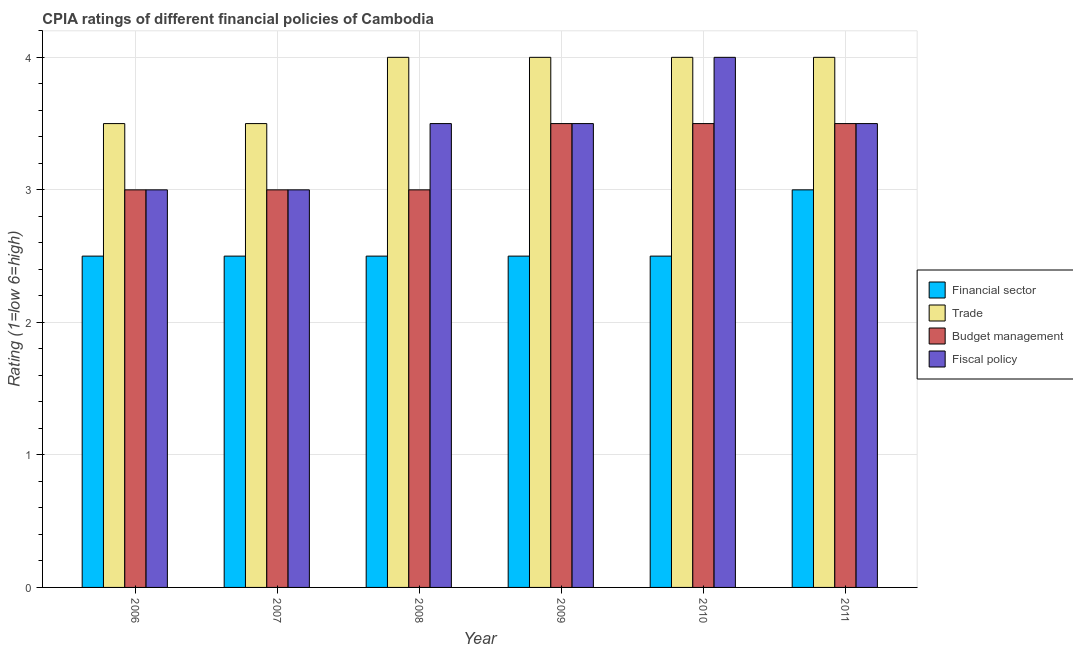How many different coloured bars are there?
Your answer should be compact. 4. Are the number of bars per tick equal to the number of legend labels?
Offer a terse response. Yes. Are the number of bars on each tick of the X-axis equal?
Offer a very short reply. Yes. How many bars are there on the 2nd tick from the right?
Make the answer very short. 4. In how many cases, is the number of bars for a given year not equal to the number of legend labels?
Provide a succinct answer. 0. Across all years, what is the maximum cpia rating of financial sector?
Give a very brief answer. 3. In which year was the cpia rating of fiscal policy maximum?
Your answer should be compact. 2010. In which year was the cpia rating of budget management minimum?
Your answer should be very brief. 2006. What is the difference between the cpia rating of fiscal policy in 2010 and the cpia rating of trade in 2006?
Your answer should be compact. 1. What is the average cpia rating of fiscal policy per year?
Ensure brevity in your answer.  3.42. In the year 2006, what is the difference between the cpia rating of budget management and cpia rating of fiscal policy?
Keep it short and to the point. 0. In how many years, is the cpia rating of financial sector greater than 1.6?
Your answer should be very brief. 6. What is the ratio of the cpia rating of financial sector in 2006 to that in 2009?
Your answer should be very brief. 1. Is the cpia rating of fiscal policy in 2010 less than that in 2011?
Offer a very short reply. No. What is the difference between the highest and the second highest cpia rating of fiscal policy?
Provide a short and direct response. 0.5. What is the difference between the highest and the lowest cpia rating of financial sector?
Offer a terse response. 0.5. Is it the case that in every year, the sum of the cpia rating of trade and cpia rating of budget management is greater than the sum of cpia rating of financial sector and cpia rating of fiscal policy?
Your answer should be very brief. No. What does the 3rd bar from the left in 2010 represents?
Ensure brevity in your answer.  Budget management. What does the 3rd bar from the right in 2008 represents?
Ensure brevity in your answer.  Trade. Is it the case that in every year, the sum of the cpia rating of financial sector and cpia rating of trade is greater than the cpia rating of budget management?
Offer a terse response. Yes. How many years are there in the graph?
Your answer should be very brief. 6. Does the graph contain grids?
Offer a very short reply. Yes. How many legend labels are there?
Ensure brevity in your answer.  4. How are the legend labels stacked?
Make the answer very short. Vertical. What is the title of the graph?
Provide a succinct answer. CPIA ratings of different financial policies of Cambodia. What is the Rating (1=low 6=high) in Financial sector in 2006?
Make the answer very short. 2.5. What is the Rating (1=low 6=high) of Fiscal policy in 2006?
Provide a succinct answer. 3. What is the Rating (1=low 6=high) in Financial sector in 2007?
Offer a very short reply. 2.5. What is the Rating (1=low 6=high) of Trade in 2007?
Your response must be concise. 3.5. What is the Rating (1=low 6=high) of Fiscal policy in 2007?
Your answer should be very brief. 3. What is the Rating (1=low 6=high) in Trade in 2008?
Offer a terse response. 4. What is the Rating (1=low 6=high) of Budget management in 2008?
Offer a terse response. 3. What is the Rating (1=low 6=high) of Fiscal policy in 2008?
Ensure brevity in your answer.  3.5. What is the Rating (1=low 6=high) in Trade in 2009?
Provide a succinct answer. 4. What is the Rating (1=low 6=high) in Budget management in 2009?
Give a very brief answer. 3.5. What is the Rating (1=low 6=high) in Fiscal policy in 2009?
Ensure brevity in your answer.  3.5. What is the Rating (1=low 6=high) in Financial sector in 2010?
Offer a very short reply. 2.5. What is the Rating (1=low 6=high) in Trade in 2010?
Your answer should be compact. 4. What is the Rating (1=low 6=high) in Financial sector in 2011?
Ensure brevity in your answer.  3. Across all years, what is the maximum Rating (1=low 6=high) in Financial sector?
Your answer should be compact. 3. Across all years, what is the maximum Rating (1=low 6=high) in Trade?
Make the answer very short. 4. Across all years, what is the maximum Rating (1=low 6=high) of Fiscal policy?
Offer a terse response. 4. Across all years, what is the minimum Rating (1=low 6=high) in Budget management?
Give a very brief answer. 3. Across all years, what is the minimum Rating (1=low 6=high) in Fiscal policy?
Give a very brief answer. 3. What is the total Rating (1=low 6=high) of Financial sector in the graph?
Your answer should be compact. 15.5. What is the total Rating (1=low 6=high) in Trade in the graph?
Offer a terse response. 23. What is the total Rating (1=low 6=high) in Fiscal policy in the graph?
Your response must be concise. 20.5. What is the difference between the Rating (1=low 6=high) in Financial sector in 2006 and that in 2007?
Keep it short and to the point. 0. What is the difference between the Rating (1=low 6=high) in Fiscal policy in 2006 and that in 2007?
Ensure brevity in your answer.  0. What is the difference between the Rating (1=low 6=high) of Trade in 2006 and that in 2008?
Your answer should be very brief. -0.5. What is the difference between the Rating (1=low 6=high) of Budget management in 2006 and that in 2008?
Your answer should be very brief. 0. What is the difference between the Rating (1=low 6=high) of Fiscal policy in 2006 and that in 2008?
Ensure brevity in your answer.  -0.5. What is the difference between the Rating (1=low 6=high) of Financial sector in 2006 and that in 2009?
Make the answer very short. 0. What is the difference between the Rating (1=low 6=high) of Budget management in 2006 and that in 2009?
Ensure brevity in your answer.  -0.5. What is the difference between the Rating (1=low 6=high) in Fiscal policy in 2006 and that in 2009?
Your answer should be very brief. -0.5. What is the difference between the Rating (1=low 6=high) in Financial sector in 2006 and that in 2010?
Your answer should be compact. 0. What is the difference between the Rating (1=low 6=high) in Fiscal policy in 2006 and that in 2010?
Your answer should be compact. -1. What is the difference between the Rating (1=low 6=high) in Financial sector in 2006 and that in 2011?
Provide a succinct answer. -0.5. What is the difference between the Rating (1=low 6=high) in Trade in 2006 and that in 2011?
Your answer should be very brief. -0.5. What is the difference between the Rating (1=low 6=high) of Budget management in 2006 and that in 2011?
Ensure brevity in your answer.  -0.5. What is the difference between the Rating (1=low 6=high) in Fiscal policy in 2006 and that in 2011?
Offer a very short reply. -0.5. What is the difference between the Rating (1=low 6=high) of Financial sector in 2007 and that in 2008?
Keep it short and to the point. 0. What is the difference between the Rating (1=low 6=high) in Trade in 2007 and that in 2008?
Offer a terse response. -0.5. What is the difference between the Rating (1=low 6=high) in Budget management in 2007 and that in 2008?
Offer a terse response. 0. What is the difference between the Rating (1=low 6=high) of Fiscal policy in 2007 and that in 2008?
Your response must be concise. -0.5. What is the difference between the Rating (1=low 6=high) in Trade in 2007 and that in 2009?
Make the answer very short. -0.5. What is the difference between the Rating (1=low 6=high) in Fiscal policy in 2007 and that in 2010?
Your answer should be very brief. -1. What is the difference between the Rating (1=low 6=high) of Trade in 2007 and that in 2011?
Provide a short and direct response. -0.5. What is the difference between the Rating (1=low 6=high) of Budget management in 2007 and that in 2011?
Keep it short and to the point. -0.5. What is the difference between the Rating (1=low 6=high) in Financial sector in 2008 and that in 2010?
Your answer should be very brief. 0. What is the difference between the Rating (1=low 6=high) in Trade in 2008 and that in 2010?
Your response must be concise. 0. What is the difference between the Rating (1=low 6=high) of Budget management in 2008 and that in 2010?
Your answer should be very brief. -0.5. What is the difference between the Rating (1=low 6=high) in Budget management in 2008 and that in 2011?
Ensure brevity in your answer.  -0.5. What is the difference between the Rating (1=low 6=high) in Budget management in 2009 and that in 2010?
Give a very brief answer. 0. What is the difference between the Rating (1=low 6=high) of Fiscal policy in 2009 and that in 2010?
Your answer should be compact. -0.5. What is the difference between the Rating (1=low 6=high) in Trade in 2009 and that in 2011?
Your response must be concise. 0. What is the difference between the Rating (1=low 6=high) in Financial sector in 2010 and that in 2011?
Make the answer very short. -0.5. What is the difference between the Rating (1=low 6=high) of Financial sector in 2006 and the Rating (1=low 6=high) of Fiscal policy in 2008?
Ensure brevity in your answer.  -1. What is the difference between the Rating (1=low 6=high) of Trade in 2006 and the Rating (1=low 6=high) of Fiscal policy in 2008?
Keep it short and to the point. 0. What is the difference between the Rating (1=low 6=high) of Budget management in 2006 and the Rating (1=low 6=high) of Fiscal policy in 2008?
Provide a succinct answer. -0.5. What is the difference between the Rating (1=low 6=high) of Financial sector in 2006 and the Rating (1=low 6=high) of Trade in 2009?
Keep it short and to the point. -1.5. What is the difference between the Rating (1=low 6=high) of Financial sector in 2006 and the Rating (1=low 6=high) of Fiscal policy in 2009?
Ensure brevity in your answer.  -1. What is the difference between the Rating (1=low 6=high) in Trade in 2006 and the Rating (1=low 6=high) in Fiscal policy in 2009?
Offer a terse response. 0. What is the difference between the Rating (1=low 6=high) in Financial sector in 2006 and the Rating (1=low 6=high) in Fiscal policy in 2010?
Give a very brief answer. -1.5. What is the difference between the Rating (1=low 6=high) of Trade in 2006 and the Rating (1=low 6=high) of Fiscal policy in 2010?
Offer a very short reply. -0.5. What is the difference between the Rating (1=low 6=high) of Financial sector in 2006 and the Rating (1=low 6=high) of Trade in 2011?
Your answer should be very brief. -1.5. What is the difference between the Rating (1=low 6=high) of Financial sector in 2006 and the Rating (1=low 6=high) of Budget management in 2011?
Ensure brevity in your answer.  -1. What is the difference between the Rating (1=low 6=high) in Financial sector in 2006 and the Rating (1=low 6=high) in Fiscal policy in 2011?
Ensure brevity in your answer.  -1. What is the difference between the Rating (1=low 6=high) of Trade in 2006 and the Rating (1=low 6=high) of Budget management in 2011?
Ensure brevity in your answer.  0. What is the difference between the Rating (1=low 6=high) in Trade in 2006 and the Rating (1=low 6=high) in Fiscal policy in 2011?
Offer a terse response. 0. What is the difference between the Rating (1=low 6=high) of Financial sector in 2007 and the Rating (1=low 6=high) of Trade in 2008?
Make the answer very short. -1.5. What is the difference between the Rating (1=low 6=high) in Trade in 2007 and the Rating (1=low 6=high) in Budget management in 2008?
Your answer should be compact. 0.5. What is the difference between the Rating (1=low 6=high) of Trade in 2007 and the Rating (1=low 6=high) of Fiscal policy in 2008?
Offer a terse response. 0. What is the difference between the Rating (1=low 6=high) of Budget management in 2007 and the Rating (1=low 6=high) of Fiscal policy in 2008?
Your answer should be compact. -0.5. What is the difference between the Rating (1=low 6=high) in Financial sector in 2007 and the Rating (1=low 6=high) in Trade in 2009?
Keep it short and to the point. -1.5. What is the difference between the Rating (1=low 6=high) of Financial sector in 2007 and the Rating (1=low 6=high) of Fiscal policy in 2009?
Offer a very short reply. -1. What is the difference between the Rating (1=low 6=high) of Financial sector in 2007 and the Rating (1=low 6=high) of Budget management in 2010?
Offer a terse response. -1. What is the difference between the Rating (1=low 6=high) of Financial sector in 2007 and the Rating (1=low 6=high) of Fiscal policy in 2010?
Provide a succinct answer. -1.5. What is the difference between the Rating (1=low 6=high) of Trade in 2007 and the Rating (1=low 6=high) of Budget management in 2010?
Give a very brief answer. 0. What is the difference between the Rating (1=low 6=high) of Trade in 2007 and the Rating (1=low 6=high) of Fiscal policy in 2010?
Provide a short and direct response. -0.5. What is the difference between the Rating (1=low 6=high) in Financial sector in 2007 and the Rating (1=low 6=high) in Budget management in 2011?
Your response must be concise. -1. What is the difference between the Rating (1=low 6=high) of Financial sector in 2007 and the Rating (1=low 6=high) of Fiscal policy in 2011?
Your response must be concise. -1. What is the difference between the Rating (1=low 6=high) of Trade in 2007 and the Rating (1=low 6=high) of Budget management in 2011?
Your answer should be compact. 0. What is the difference between the Rating (1=low 6=high) of Budget management in 2007 and the Rating (1=low 6=high) of Fiscal policy in 2011?
Give a very brief answer. -0.5. What is the difference between the Rating (1=low 6=high) of Financial sector in 2008 and the Rating (1=low 6=high) of Budget management in 2009?
Your answer should be very brief. -1. What is the difference between the Rating (1=low 6=high) of Financial sector in 2008 and the Rating (1=low 6=high) of Budget management in 2010?
Offer a terse response. -1. What is the difference between the Rating (1=low 6=high) in Financial sector in 2008 and the Rating (1=low 6=high) in Fiscal policy in 2010?
Ensure brevity in your answer.  -1.5. What is the difference between the Rating (1=low 6=high) in Budget management in 2008 and the Rating (1=low 6=high) in Fiscal policy in 2010?
Provide a short and direct response. -1. What is the difference between the Rating (1=low 6=high) of Financial sector in 2008 and the Rating (1=low 6=high) of Trade in 2011?
Make the answer very short. -1.5. What is the difference between the Rating (1=low 6=high) of Financial sector in 2008 and the Rating (1=low 6=high) of Budget management in 2011?
Ensure brevity in your answer.  -1. What is the difference between the Rating (1=low 6=high) in Trade in 2008 and the Rating (1=low 6=high) in Budget management in 2011?
Your answer should be very brief. 0.5. What is the difference between the Rating (1=low 6=high) in Trade in 2008 and the Rating (1=low 6=high) in Fiscal policy in 2011?
Your answer should be very brief. 0.5. What is the difference between the Rating (1=low 6=high) in Financial sector in 2009 and the Rating (1=low 6=high) in Trade in 2010?
Your response must be concise. -1.5. What is the difference between the Rating (1=low 6=high) in Financial sector in 2009 and the Rating (1=low 6=high) in Budget management in 2010?
Offer a very short reply. -1. What is the difference between the Rating (1=low 6=high) in Budget management in 2009 and the Rating (1=low 6=high) in Fiscal policy in 2010?
Keep it short and to the point. -0.5. What is the difference between the Rating (1=low 6=high) in Financial sector in 2009 and the Rating (1=low 6=high) in Trade in 2011?
Provide a succinct answer. -1.5. What is the difference between the Rating (1=low 6=high) in Trade in 2009 and the Rating (1=low 6=high) in Fiscal policy in 2011?
Keep it short and to the point. 0.5. What is the difference between the Rating (1=low 6=high) of Budget management in 2009 and the Rating (1=low 6=high) of Fiscal policy in 2011?
Keep it short and to the point. 0. What is the difference between the Rating (1=low 6=high) in Financial sector in 2010 and the Rating (1=low 6=high) in Trade in 2011?
Provide a short and direct response. -1.5. What is the difference between the Rating (1=low 6=high) of Financial sector in 2010 and the Rating (1=low 6=high) of Budget management in 2011?
Your response must be concise. -1. What is the difference between the Rating (1=low 6=high) of Trade in 2010 and the Rating (1=low 6=high) of Budget management in 2011?
Offer a very short reply. 0.5. What is the difference between the Rating (1=low 6=high) in Trade in 2010 and the Rating (1=low 6=high) in Fiscal policy in 2011?
Make the answer very short. 0.5. What is the difference between the Rating (1=low 6=high) of Budget management in 2010 and the Rating (1=low 6=high) of Fiscal policy in 2011?
Make the answer very short. 0. What is the average Rating (1=low 6=high) in Financial sector per year?
Make the answer very short. 2.58. What is the average Rating (1=low 6=high) in Trade per year?
Provide a succinct answer. 3.83. What is the average Rating (1=low 6=high) of Budget management per year?
Provide a short and direct response. 3.25. What is the average Rating (1=low 6=high) of Fiscal policy per year?
Your response must be concise. 3.42. In the year 2006, what is the difference between the Rating (1=low 6=high) in Financial sector and Rating (1=low 6=high) in Fiscal policy?
Offer a terse response. -0.5. In the year 2006, what is the difference between the Rating (1=low 6=high) of Trade and Rating (1=low 6=high) of Budget management?
Provide a succinct answer. 0.5. In the year 2007, what is the difference between the Rating (1=low 6=high) of Financial sector and Rating (1=low 6=high) of Budget management?
Provide a short and direct response. -0.5. In the year 2007, what is the difference between the Rating (1=low 6=high) of Trade and Rating (1=low 6=high) of Budget management?
Provide a succinct answer. 0.5. In the year 2008, what is the difference between the Rating (1=low 6=high) in Financial sector and Rating (1=low 6=high) in Fiscal policy?
Give a very brief answer. -1. In the year 2008, what is the difference between the Rating (1=low 6=high) of Trade and Rating (1=low 6=high) of Budget management?
Your answer should be very brief. 1. In the year 2009, what is the difference between the Rating (1=low 6=high) in Financial sector and Rating (1=low 6=high) in Trade?
Ensure brevity in your answer.  -1.5. In the year 2009, what is the difference between the Rating (1=low 6=high) in Financial sector and Rating (1=low 6=high) in Budget management?
Your answer should be very brief. -1. In the year 2009, what is the difference between the Rating (1=low 6=high) of Trade and Rating (1=low 6=high) of Budget management?
Provide a short and direct response. 0.5. In the year 2009, what is the difference between the Rating (1=low 6=high) of Trade and Rating (1=low 6=high) of Fiscal policy?
Provide a succinct answer. 0.5. In the year 2009, what is the difference between the Rating (1=low 6=high) of Budget management and Rating (1=low 6=high) of Fiscal policy?
Offer a very short reply. 0. In the year 2010, what is the difference between the Rating (1=low 6=high) in Financial sector and Rating (1=low 6=high) in Trade?
Keep it short and to the point. -1.5. In the year 2010, what is the difference between the Rating (1=low 6=high) of Financial sector and Rating (1=low 6=high) of Budget management?
Make the answer very short. -1. In the year 2010, what is the difference between the Rating (1=low 6=high) of Financial sector and Rating (1=low 6=high) of Fiscal policy?
Your response must be concise. -1.5. In the year 2010, what is the difference between the Rating (1=low 6=high) in Trade and Rating (1=low 6=high) in Budget management?
Make the answer very short. 0.5. In the year 2011, what is the difference between the Rating (1=low 6=high) of Trade and Rating (1=low 6=high) of Budget management?
Make the answer very short. 0.5. What is the ratio of the Rating (1=low 6=high) in Budget management in 2006 to that in 2007?
Provide a short and direct response. 1. What is the ratio of the Rating (1=low 6=high) in Trade in 2006 to that in 2008?
Make the answer very short. 0.88. What is the ratio of the Rating (1=low 6=high) of Budget management in 2006 to that in 2008?
Ensure brevity in your answer.  1. What is the ratio of the Rating (1=low 6=high) in Fiscal policy in 2006 to that in 2008?
Ensure brevity in your answer.  0.86. What is the ratio of the Rating (1=low 6=high) in Financial sector in 2006 to that in 2009?
Your answer should be compact. 1. What is the ratio of the Rating (1=low 6=high) of Trade in 2006 to that in 2009?
Your answer should be compact. 0.88. What is the ratio of the Rating (1=low 6=high) of Fiscal policy in 2006 to that in 2010?
Your answer should be very brief. 0.75. What is the ratio of the Rating (1=low 6=high) in Financial sector in 2006 to that in 2011?
Offer a very short reply. 0.83. What is the ratio of the Rating (1=low 6=high) of Trade in 2006 to that in 2011?
Make the answer very short. 0.88. What is the ratio of the Rating (1=low 6=high) of Budget management in 2006 to that in 2011?
Give a very brief answer. 0.86. What is the ratio of the Rating (1=low 6=high) of Fiscal policy in 2006 to that in 2011?
Offer a very short reply. 0.86. What is the ratio of the Rating (1=low 6=high) of Trade in 2007 to that in 2008?
Keep it short and to the point. 0.88. What is the ratio of the Rating (1=low 6=high) in Budget management in 2007 to that in 2008?
Give a very brief answer. 1. What is the ratio of the Rating (1=low 6=high) of Financial sector in 2007 to that in 2009?
Your answer should be very brief. 1. What is the ratio of the Rating (1=low 6=high) of Fiscal policy in 2007 to that in 2009?
Give a very brief answer. 0.86. What is the ratio of the Rating (1=low 6=high) of Fiscal policy in 2007 to that in 2010?
Ensure brevity in your answer.  0.75. What is the ratio of the Rating (1=low 6=high) in Financial sector in 2007 to that in 2011?
Make the answer very short. 0.83. What is the ratio of the Rating (1=low 6=high) in Financial sector in 2008 to that in 2009?
Provide a succinct answer. 1. What is the ratio of the Rating (1=low 6=high) of Trade in 2008 to that in 2009?
Make the answer very short. 1. What is the ratio of the Rating (1=low 6=high) of Financial sector in 2008 to that in 2010?
Provide a succinct answer. 1. What is the ratio of the Rating (1=low 6=high) in Trade in 2008 to that in 2010?
Give a very brief answer. 1. What is the ratio of the Rating (1=low 6=high) in Budget management in 2008 to that in 2010?
Make the answer very short. 0.86. What is the ratio of the Rating (1=low 6=high) in Fiscal policy in 2008 to that in 2010?
Make the answer very short. 0.88. What is the ratio of the Rating (1=low 6=high) of Financial sector in 2008 to that in 2011?
Ensure brevity in your answer.  0.83. What is the ratio of the Rating (1=low 6=high) of Trade in 2008 to that in 2011?
Keep it short and to the point. 1. What is the ratio of the Rating (1=low 6=high) of Budget management in 2008 to that in 2011?
Offer a terse response. 0.86. What is the ratio of the Rating (1=low 6=high) in Fiscal policy in 2009 to that in 2010?
Ensure brevity in your answer.  0.88. What is the ratio of the Rating (1=low 6=high) of Trade in 2009 to that in 2011?
Keep it short and to the point. 1. What is the ratio of the Rating (1=low 6=high) in Budget management in 2009 to that in 2011?
Keep it short and to the point. 1. What is the ratio of the Rating (1=low 6=high) in Trade in 2010 to that in 2011?
Your answer should be very brief. 1. What is the ratio of the Rating (1=low 6=high) in Budget management in 2010 to that in 2011?
Your answer should be very brief. 1. What is the ratio of the Rating (1=low 6=high) of Fiscal policy in 2010 to that in 2011?
Your answer should be compact. 1.14. What is the difference between the highest and the second highest Rating (1=low 6=high) of Financial sector?
Make the answer very short. 0.5. What is the difference between the highest and the second highest Rating (1=low 6=high) of Trade?
Ensure brevity in your answer.  0. What is the difference between the highest and the second highest Rating (1=low 6=high) of Budget management?
Offer a very short reply. 0. What is the difference between the highest and the second highest Rating (1=low 6=high) of Fiscal policy?
Make the answer very short. 0.5. 